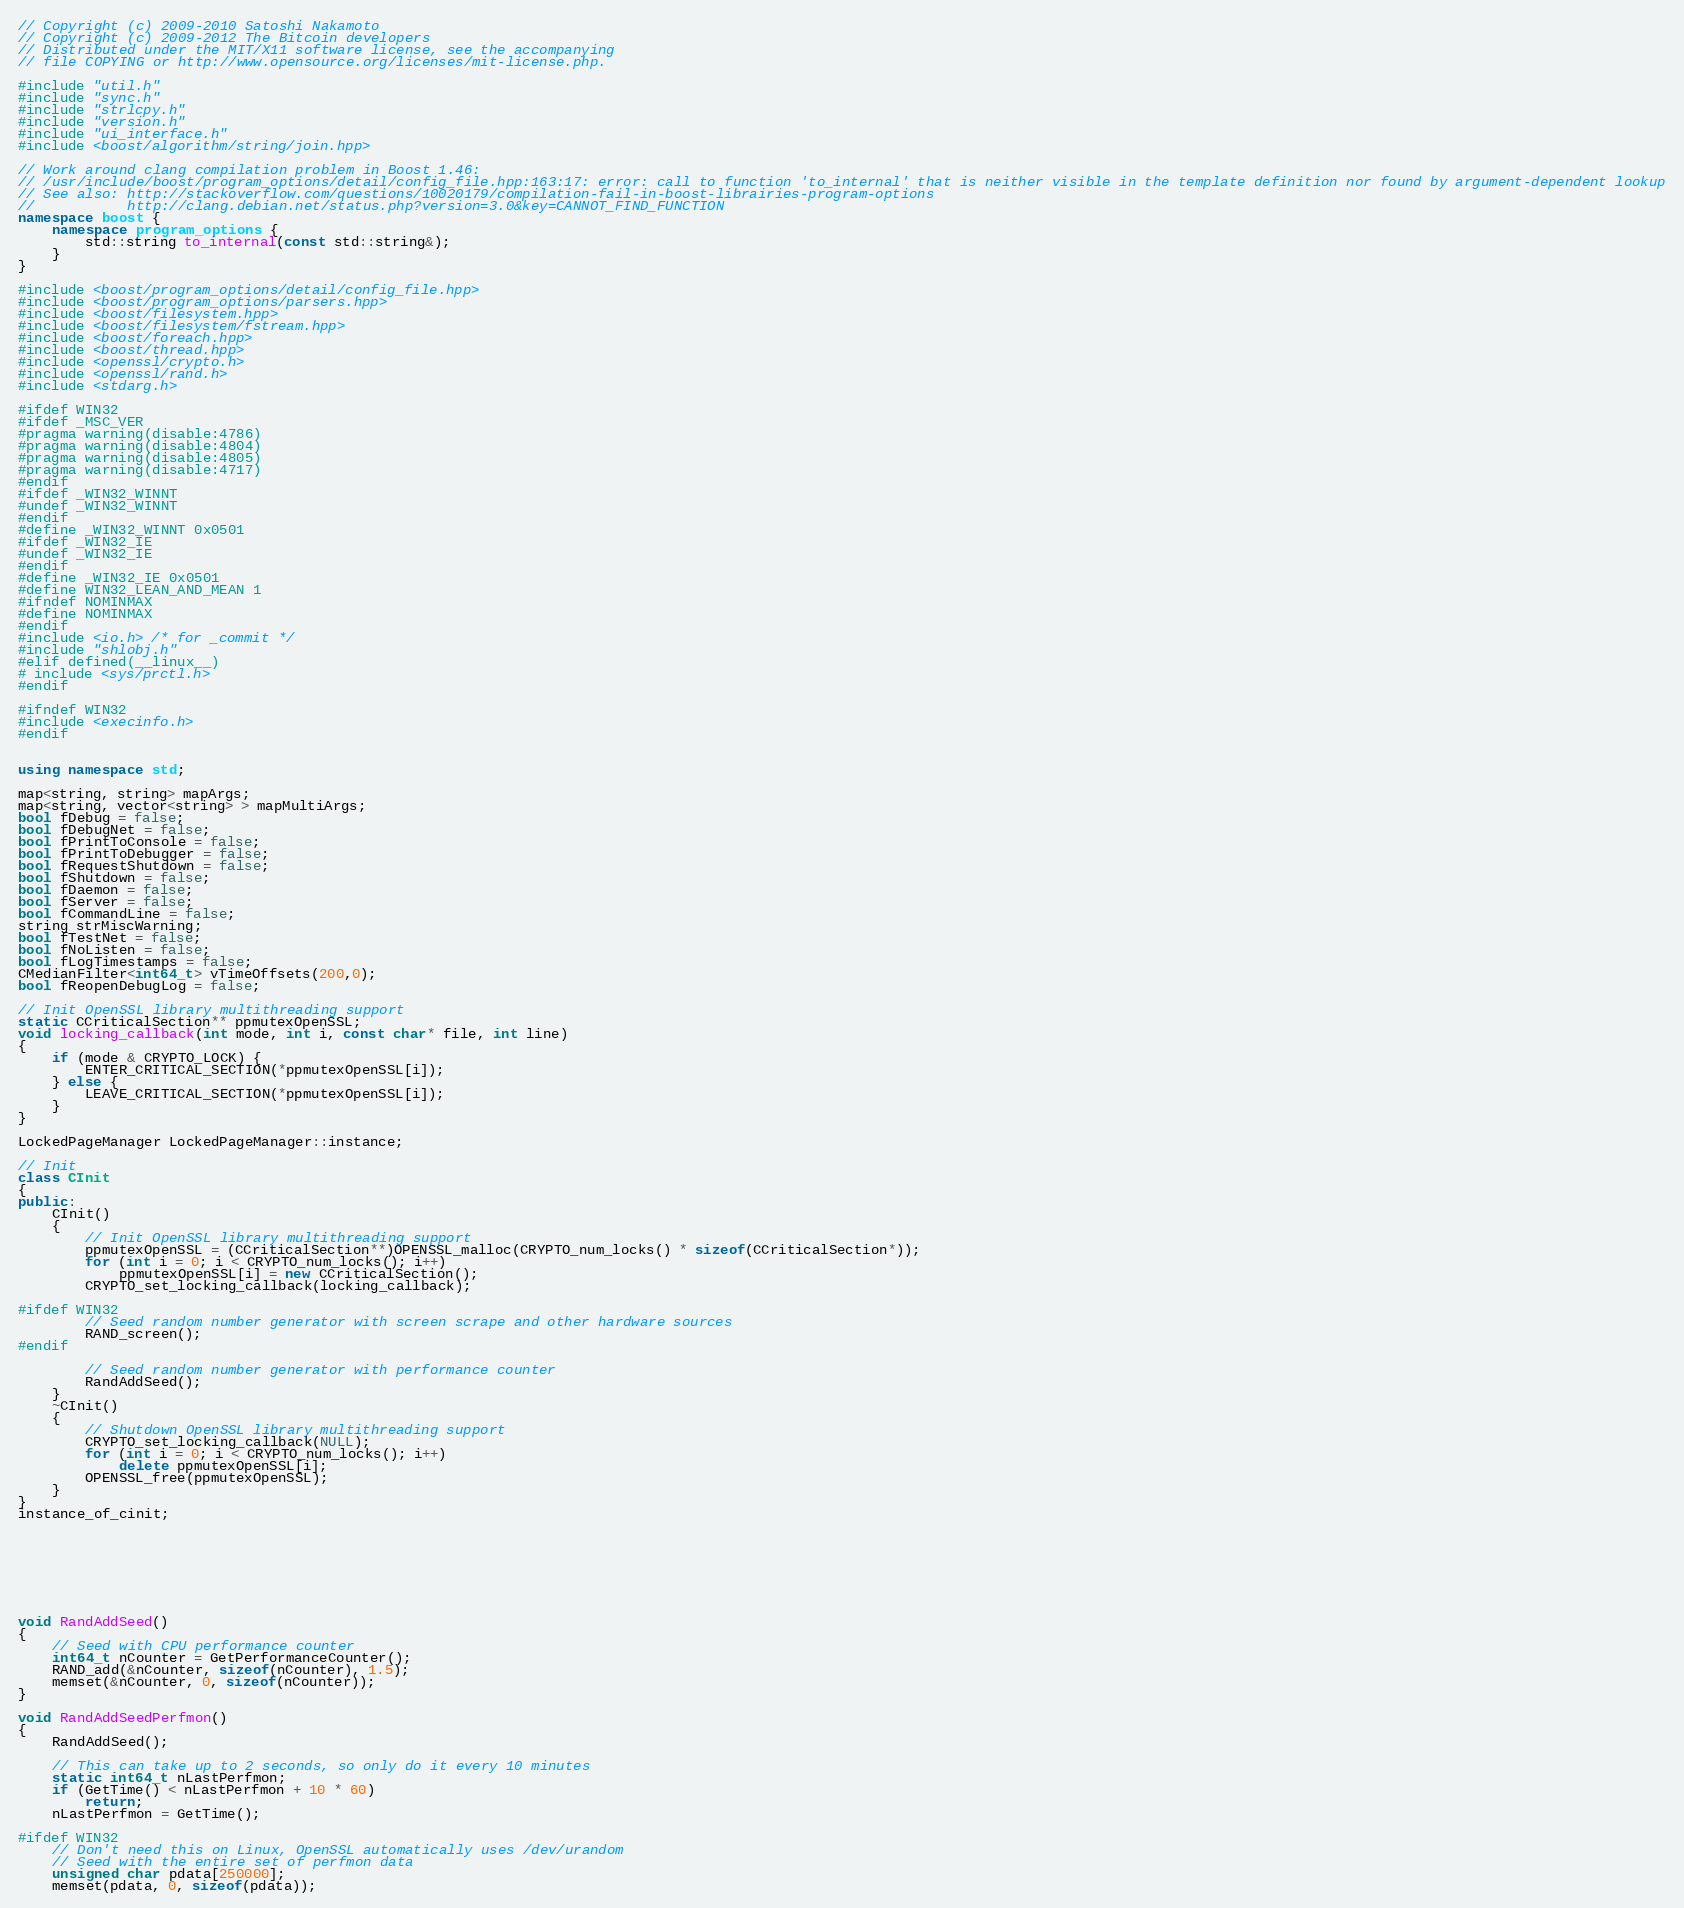<code> <loc_0><loc_0><loc_500><loc_500><_C++_>// Copyright (c) 2009-2010 Satoshi Nakamoto
// Copyright (c) 2009-2012 The Bitcoin developers
// Distributed under the MIT/X11 software license, see the accompanying
// file COPYING or http://www.opensource.org/licenses/mit-license.php.

#include "util.h"
#include "sync.h"
#include "strlcpy.h"
#include "version.h"
#include "ui_interface.h"
#include <boost/algorithm/string/join.hpp>

// Work around clang compilation problem in Boost 1.46:
// /usr/include/boost/program_options/detail/config_file.hpp:163:17: error: call to function 'to_internal' that is neither visible in the template definition nor found by argument-dependent lookup
// See also: http://stackoverflow.com/questions/10020179/compilation-fail-in-boost-librairies-program-options
//           http://clang.debian.net/status.php?version=3.0&key=CANNOT_FIND_FUNCTION
namespace boost {
    namespace program_options {
        std::string to_internal(const std::string&);
    }
}

#include <boost/program_options/detail/config_file.hpp>
#include <boost/program_options/parsers.hpp>
#include <boost/filesystem.hpp>
#include <boost/filesystem/fstream.hpp>
#include <boost/foreach.hpp>
#include <boost/thread.hpp>
#include <openssl/crypto.h>
#include <openssl/rand.h>
#include <stdarg.h>

#ifdef WIN32
#ifdef _MSC_VER
#pragma warning(disable:4786)
#pragma warning(disable:4804)
#pragma warning(disable:4805)
#pragma warning(disable:4717)
#endif
#ifdef _WIN32_WINNT
#undef _WIN32_WINNT
#endif
#define _WIN32_WINNT 0x0501
#ifdef _WIN32_IE
#undef _WIN32_IE
#endif
#define _WIN32_IE 0x0501
#define WIN32_LEAN_AND_MEAN 1
#ifndef NOMINMAX
#define NOMINMAX
#endif
#include <io.h> /* for _commit */
#include "shlobj.h"
#elif defined(__linux__)
# include <sys/prctl.h>
#endif

#ifndef WIN32
#include <execinfo.h>
#endif


using namespace std;

map<string, string> mapArgs;
map<string, vector<string> > mapMultiArgs;
bool fDebug = false;
bool fDebugNet = false;
bool fPrintToConsole = false;
bool fPrintToDebugger = false;
bool fRequestShutdown = false;
bool fShutdown = false;
bool fDaemon = false;
bool fServer = false;
bool fCommandLine = false;
string strMiscWarning;
bool fTestNet = false;
bool fNoListen = false;
bool fLogTimestamps = false;
CMedianFilter<int64_t> vTimeOffsets(200,0);
bool fReopenDebugLog = false;

// Init OpenSSL library multithreading support
static CCriticalSection** ppmutexOpenSSL;
void locking_callback(int mode, int i, const char* file, int line)
{
    if (mode & CRYPTO_LOCK) {
        ENTER_CRITICAL_SECTION(*ppmutexOpenSSL[i]);
    } else {
        LEAVE_CRITICAL_SECTION(*ppmutexOpenSSL[i]);
    }
}

LockedPageManager LockedPageManager::instance;

// Init
class CInit
{
public:
    CInit()
    {
        // Init OpenSSL library multithreading support
        ppmutexOpenSSL = (CCriticalSection**)OPENSSL_malloc(CRYPTO_num_locks() * sizeof(CCriticalSection*));
        for (int i = 0; i < CRYPTO_num_locks(); i++)
            ppmutexOpenSSL[i] = new CCriticalSection();
        CRYPTO_set_locking_callback(locking_callback);

#ifdef WIN32
        // Seed random number generator with screen scrape and other hardware sources
        RAND_screen();
#endif

        // Seed random number generator with performance counter
        RandAddSeed();
    }
    ~CInit()
    {
        // Shutdown OpenSSL library multithreading support
        CRYPTO_set_locking_callback(NULL);
        for (int i = 0; i < CRYPTO_num_locks(); i++)
            delete ppmutexOpenSSL[i];
        OPENSSL_free(ppmutexOpenSSL);
    }
}
instance_of_cinit;








void RandAddSeed()
{
    // Seed with CPU performance counter
    int64_t nCounter = GetPerformanceCounter();
    RAND_add(&nCounter, sizeof(nCounter), 1.5);
    memset(&nCounter, 0, sizeof(nCounter));
}

void RandAddSeedPerfmon()
{
    RandAddSeed();

    // This can take up to 2 seconds, so only do it every 10 minutes
    static int64_t nLastPerfmon;
    if (GetTime() < nLastPerfmon + 10 * 60)
        return;
    nLastPerfmon = GetTime();

#ifdef WIN32
    // Don't need this on Linux, OpenSSL automatically uses /dev/urandom
    // Seed with the entire set of perfmon data
    unsigned char pdata[250000];
    memset(pdata, 0, sizeof(pdata));</code> 